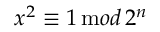<formula> <loc_0><loc_0><loc_500><loc_500>x ^ { 2 } \equiv 1 \, { \mathrm m o d } \, 2 ^ { n }</formula> 